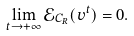Convert formula to latex. <formula><loc_0><loc_0><loc_500><loc_500>\lim _ { t \rightarrow + \infty } \mathcal { E } _ { C _ { R } } ( v ^ { t } ) = 0 .</formula> 